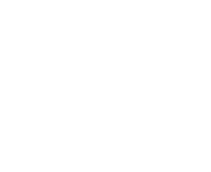<chart> <loc_0><loc_0><loc_500><loc_500><pie_chart><ecel><fcel>Cash collateral for loaned<fcel>Securities sold but not yet<fcel>Total(1)<fcel>Portion of above securities<nl><fcel>30.07%<fcel>11.87%<fcel>0.03%<fcel>41.97%<fcel>16.07%<nl></chart> 